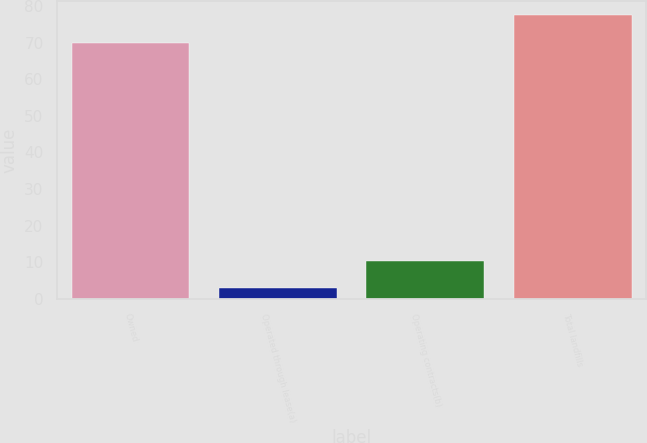Convert chart to OTSL. <chart><loc_0><loc_0><loc_500><loc_500><bar_chart><fcel>Owned<fcel>Operated through lease(a)<fcel>Operating contracts(b)<fcel>Total landfills<nl><fcel>70<fcel>3<fcel>10.4<fcel>77.4<nl></chart> 